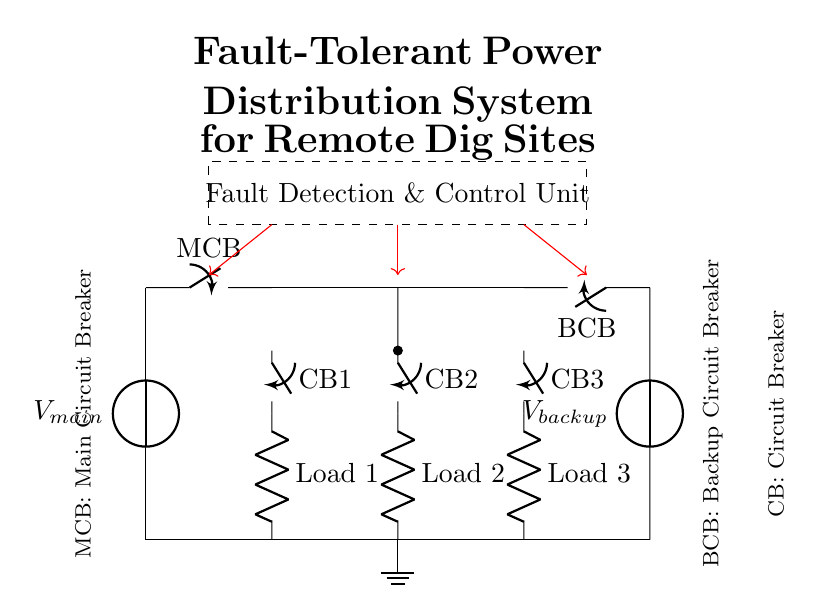What are the two power sources in the circuit? The circuit contains a main power source labeled ${V_{main}}$ and a backup power source labeled ${V_{backup}}$. Both power sources are represented at the left and right side of the circuit diagram, respectively.
Answer: Main and backup What does MCB stand for in this circuit? MCB stands for Main Circuit Breaker, which is indicated on the diagram next to the symbol that represents it. This component is crucial for controlling the electrical flow from the main power source.
Answer: Main Circuit Breaker What is the role of the Fault Detection Unit? The Fault Detection Unit, indicated by a dashed rectangle, is responsible for identifying faults within the system and coordinating control actions to manage those faults, ensuring system reliability.
Answer: Fault identification and control How many circuit breakers are there in total? The circuit has three circuit breakers (CB1, CB2, and CB3) indicated by the labels in the circuit diagram, each connected to different loads.
Answer: Three Which component provides backup power protection? The Backup Circuit Breaker (BCB) provides protection for the backup power source, ensuring that power can be redirected safely in the event of a primary circuit failure. This is shown on the right side of the circuit diagram.
Answer: Backup Circuit Breaker Explain the connection type used between the two power sources and the load circuits. The main and backup power sources are connected to a bus bar. This allows both power sources to supply power to the load circuits. The circuit breakers on each branch ensure that power can be controlled effectively, allowing for fault tolerance. Thus, if one source fails, the other can maintain power to the load.
Answer: Bus bar connections 